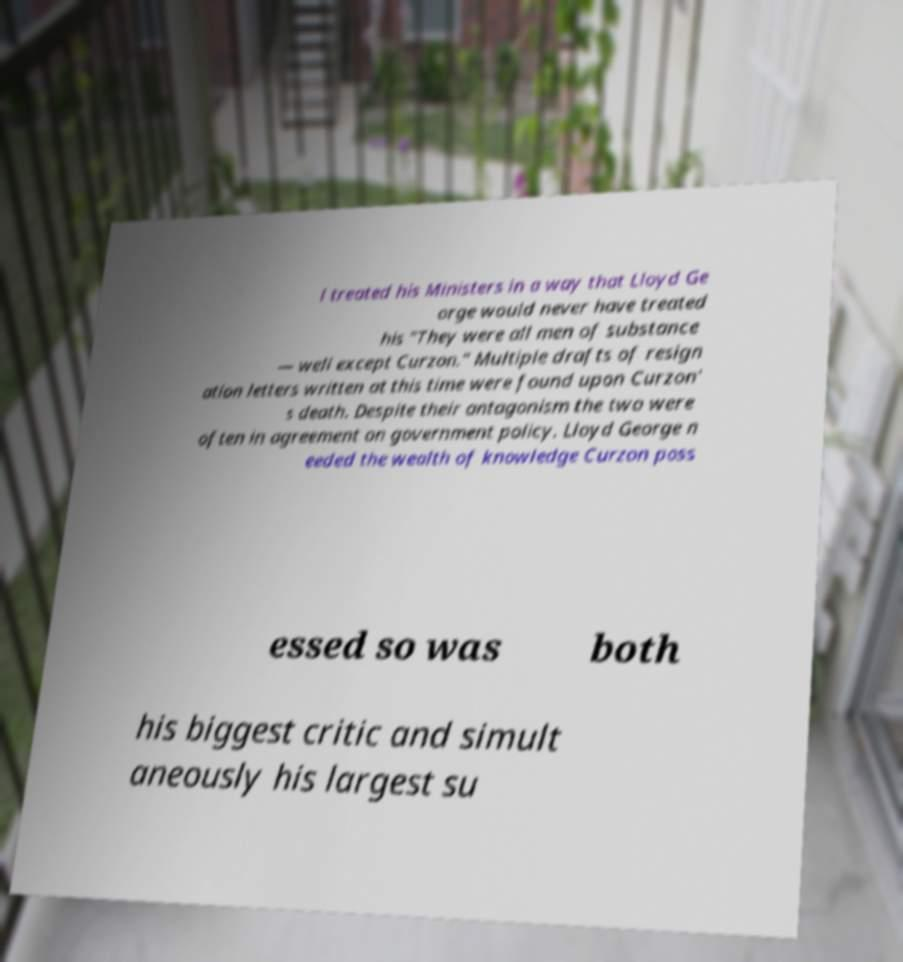There's text embedded in this image that I need extracted. Can you transcribe it verbatim? l treated his Ministers in a way that Lloyd Ge orge would never have treated his "They were all men of substance — well except Curzon." Multiple drafts of resign ation letters written at this time were found upon Curzon' s death. Despite their antagonism the two were often in agreement on government policy. Lloyd George n eeded the wealth of knowledge Curzon poss essed so was both his biggest critic and simult aneously his largest su 